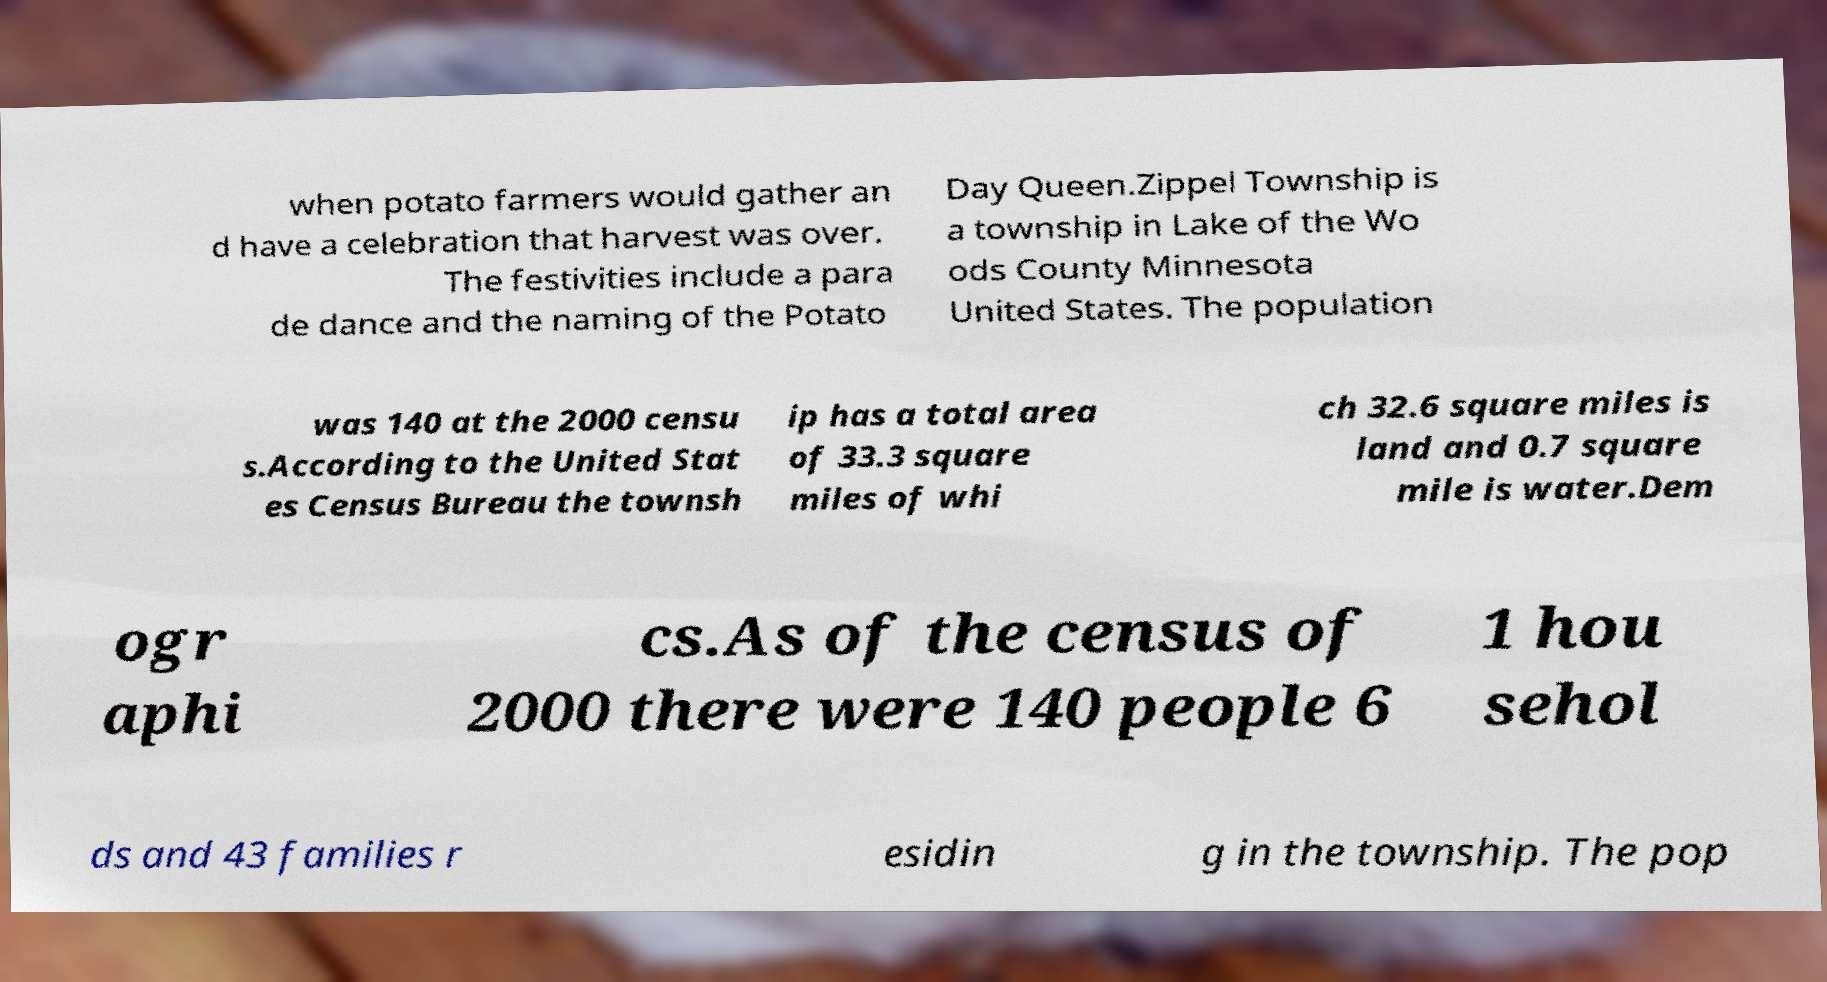I need the written content from this picture converted into text. Can you do that? when potato farmers would gather an d have a celebration that harvest was over. The festivities include a para de dance and the naming of the Potato Day Queen.Zippel Township is a township in Lake of the Wo ods County Minnesota United States. The population was 140 at the 2000 censu s.According to the United Stat es Census Bureau the townsh ip has a total area of 33.3 square miles of whi ch 32.6 square miles is land and 0.7 square mile is water.Dem ogr aphi cs.As of the census of 2000 there were 140 people 6 1 hou sehol ds and 43 families r esidin g in the township. The pop 